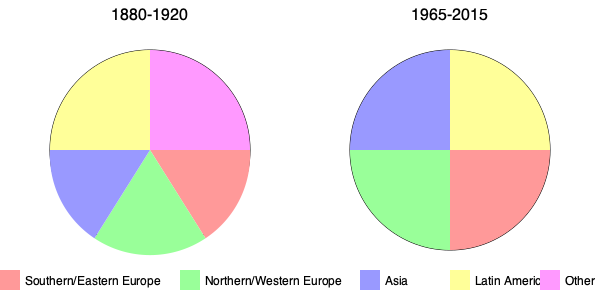Based on the pie charts showing the ethnic composition of immigrants during two different periods in U.S. history, which group saw the most significant increase in proportion from 1880-1920 to 1965-2015? To answer this question, we need to compare the proportions of each ethnic group between the two time periods:

1. Southern/Eastern Europe:
   1880-1920: Approximately 35%
   1965-2015: Approximately 25%
   Change: Decrease

2. Northern/Western Europe:
   1880-1920: Approximately 25%
   1965-2015: Approximately 25%
   Change: Minimal change

3. Asia:
   1880-1920: Approximately 15%
   1965-2015: Approximately 25%
   Change: Increase of about 10%

4. Latin America:
   1880-1920: Approximately 15%
   1965-2015: Approximately 25%
   Change: Increase of about 10%

5. Other:
   1880-1920: Approximately 10%
   1965-2015: Not represented (or very small)
   Change: Decrease

Among these groups, both Asia and Latin America show significant increases. However, the increase for Latin America appears to be slightly larger, going from a smaller slice in the 1880-1920 chart to an equal quarter of the pie in the 1965-2015 chart.
Answer: Latin America 